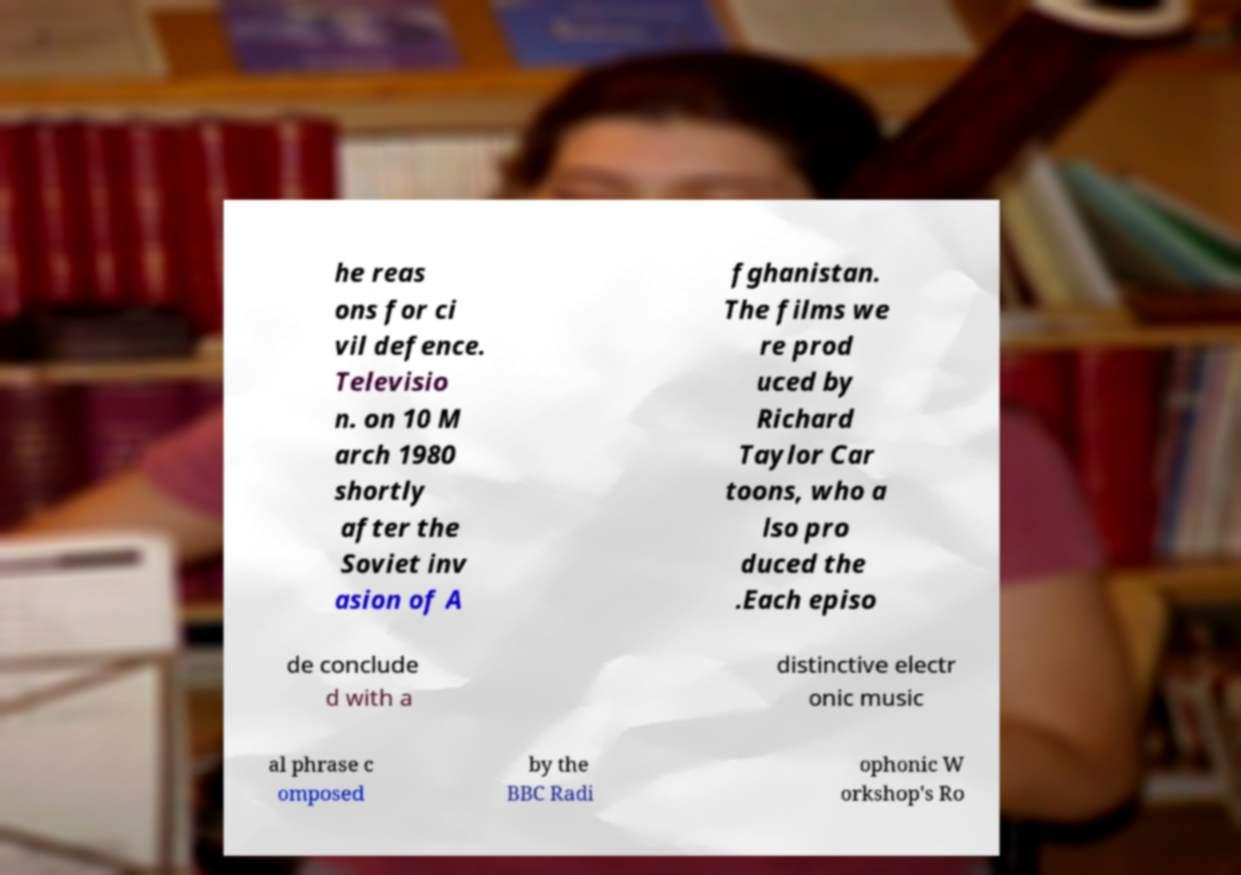Can you accurately transcribe the text from the provided image for me? he reas ons for ci vil defence. Televisio n. on 10 M arch 1980 shortly after the Soviet inv asion of A fghanistan. The films we re prod uced by Richard Taylor Car toons, who a lso pro duced the .Each episo de conclude d with a distinctive electr onic music al phrase c omposed by the BBC Radi ophonic W orkshop's Ro 